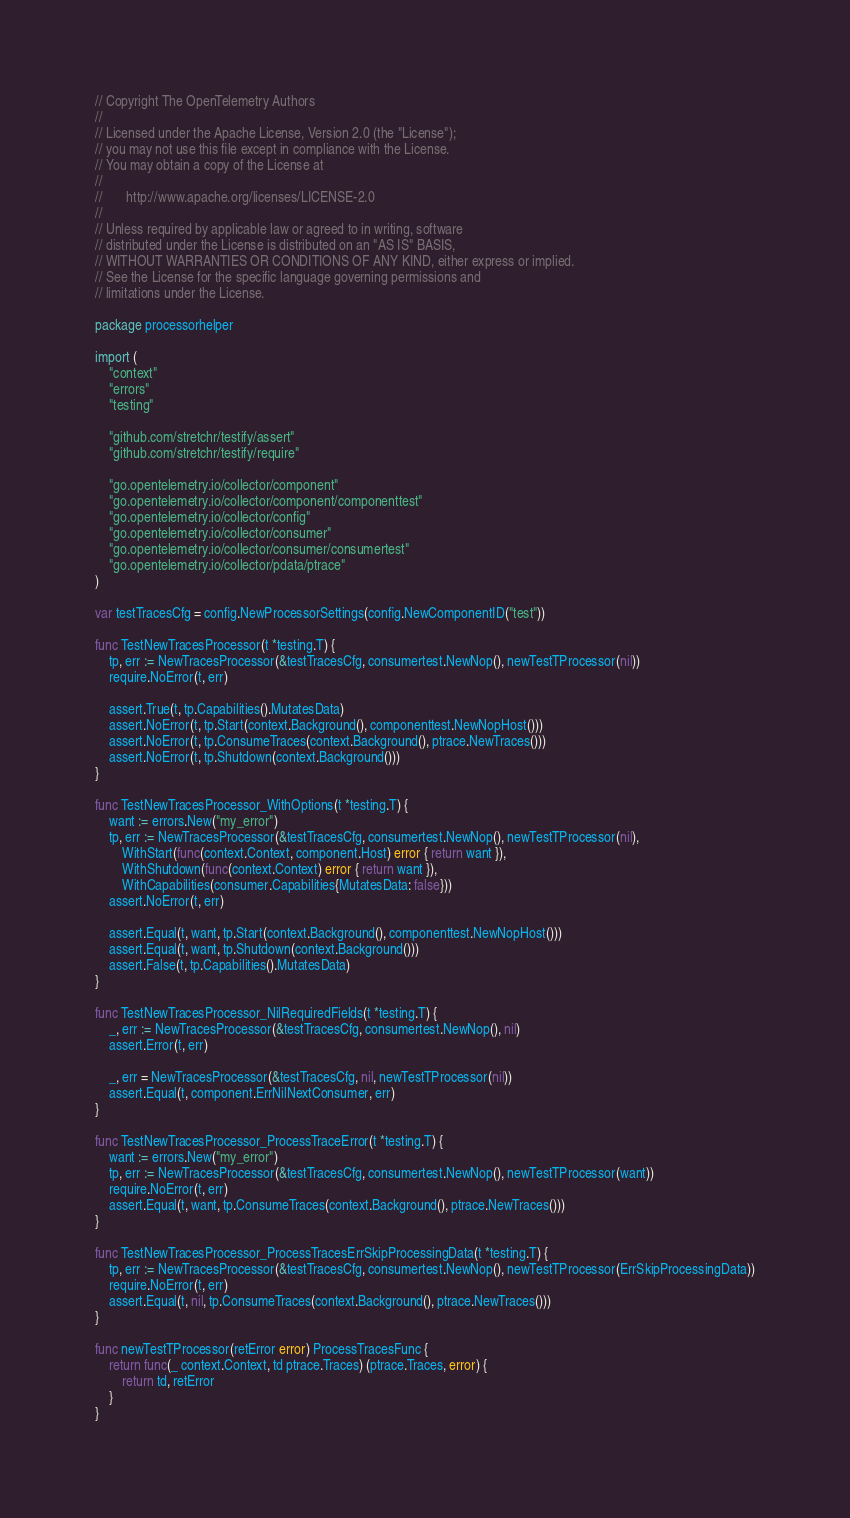Convert code to text. <code><loc_0><loc_0><loc_500><loc_500><_Go_>// Copyright The OpenTelemetry Authors
//
// Licensed under the Apache License, Version 2.0 (the "License");
// you may not use this file except in compliance with the License.
// You may obtain a copy of the License at
//
//       http://www.apache.org/licenses/LICENSE-2.0
//
// Unless required by applicable law or agreed to in writing, software
// distributed under the License is distributed on an "AS IS" BASIS,
// WITHOUT WARRANTIES OR CONDITIONS OF ANY KIND, either express or implied.
// See the License for the specific language governing permissions and
// limitations under the License.

package processorhelper

import (
	"context"
	"errors"
	"testing"

	"github.com/stretchr/testify/assert"
	"github.com/stretchr/testify/require"

	"go.opentelemetry.io/collector/component"
	"go.opentelemetry.io/collector/component/componenttest"
	"go.opentelemetry.io/collector/config"
	"go.opentelemetry.io/collector/consumer"
	"go.opentelemetry.io/collector/consumer/consumertest"
	"go.opentelemetry.io/collector/pdata/ptrace"
)

var testTracesCfg = config.NewProcessorSettings(config.NewComponentID("test"))

func TestNewTracesProcessor(t *testing.T) {
	tp, err := NewTracesProcessor(&testTracesCfg, consumertest.NewNop(), newTestTProcessor(nil))
	require.NoError(t, err)

	assert.True(t, tp.Capabilities().MutatesData)
	assert.NoError(t, tp.Start(context.Background(), componenttest.NewNopHost()))
	assert.NoError(t, tp.ConsumeTraces(context.Background(), ptrace.NewTraces()))
	assert.NoError(t, tp.Shutdown(context.Background()))
}

func TestNewTracesProcessor_WithOptions(t *testing.T) {
	want := errors.New("my_error")
	tp, err := NewTracesProcessor(&testTracesCfg, consumertest.NewNop(), newTestTProcessor(nil),
		WithStart(func(context.Context, component.Host) error { return want }),
		WithShutdown(func(context.Context) error { return want }),
		WithCapabilities(consumer.Capabilities{MutatesData: false}))
	assert.NoError(t, err)

	assert.Equal(t, want, tp.Start(context.Background(), componenttest.NewNopHost()))
	assert.Equal(t, want, tp.Shutdown(context.Background()))
	assert.False(t, tp.Capabilities().MutatesData)
}

func TestNewTracesProcessor_NilRequiredFields(t *testing.T) {
	_, err := NewTracesProcessor(&testTracesCfg, consumertest.NewNop(), nil)
	assert.Error(t, err)

	_, err = NewTracesProcessor(&testTracesCfg, nil, newTestTProcessor(nil))
	assert.Equal(t, component.ErrNilNextConsumer, err)
}

func TestNewTracesProcessor_ProcessTraceError(t *testing.T) {
	want := errors.New("my_error")
	tp, err := NewTracesProcessor(&testTracesCfg, consumertest.NewNop(), newTestTProcessor(want))
	require.NoError(t, err)
	assert.Equal(t, want, tp.ConsumeTraces(context.Background(), ptrace.NewTraces()))
}

func TestNewTracesProcessor_ProcessTracesErrSkipProcessingData(t *testing.T) {
	tp, err := NewTracesProcessor(&testTracesCfg, consumertest.NewNop(), newTestTProcessor(ErrSkipProcessingData))
	require.NoError(t, err)
	assert.Equal(t, nil, tp.ConsumeTraces(context.Background(), ptrace.NewTraces()))
}

func newTestTProcessor(retError error) ProcessTracesFunc {
	return func(_ context.Context, td ptrace.Traces) (ptrace.Traces, error) {
		return td, retError
	}
}
</code> 